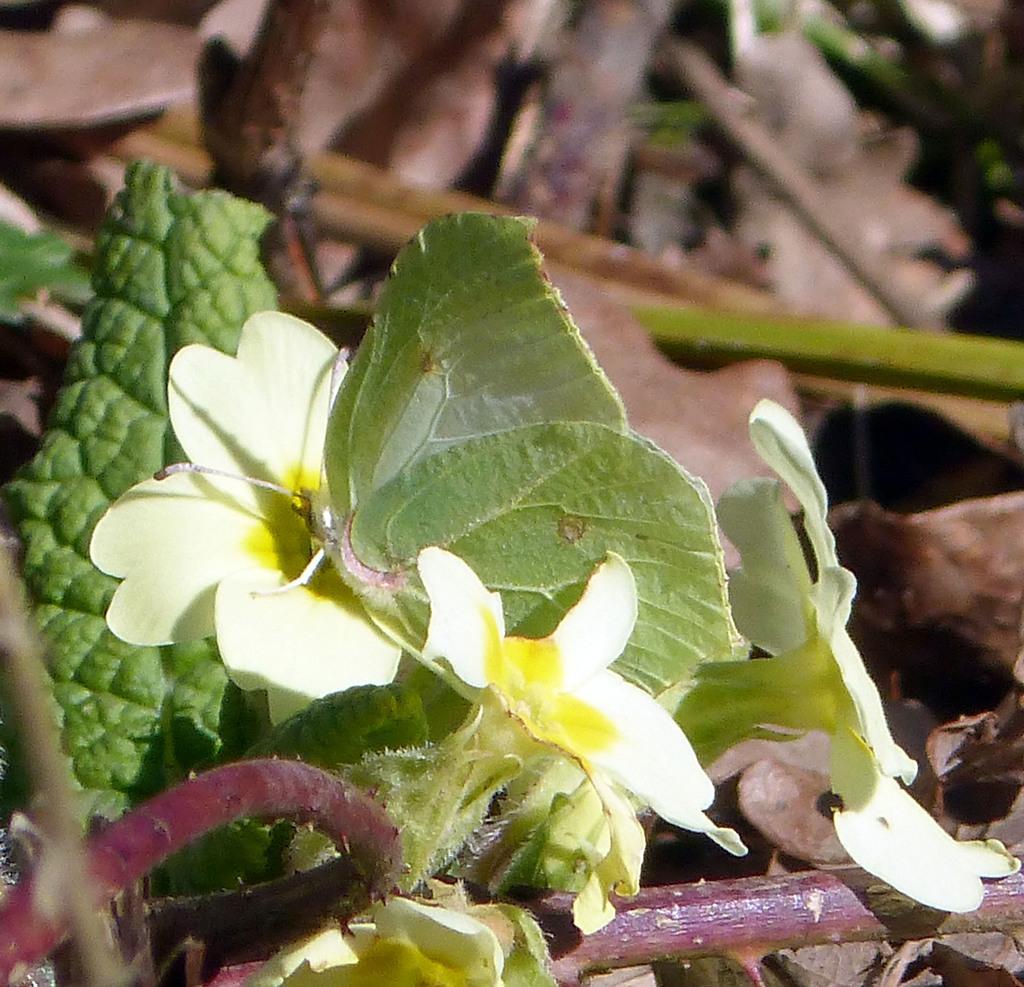Describe this image in one or two sentences. In this picture I can observe leaves which are in green color. The background is blurred. 